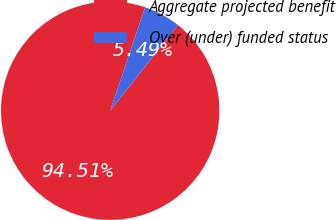Convert chart to OTSL. <chart><loc_0><loc_0><loc_500><loc_500><pie_chart><fcel>Aggregate projected benefit<fcel>Over (under) funded status<nl><fcel>94.51%<fcel>5.49%<nl></chart> 